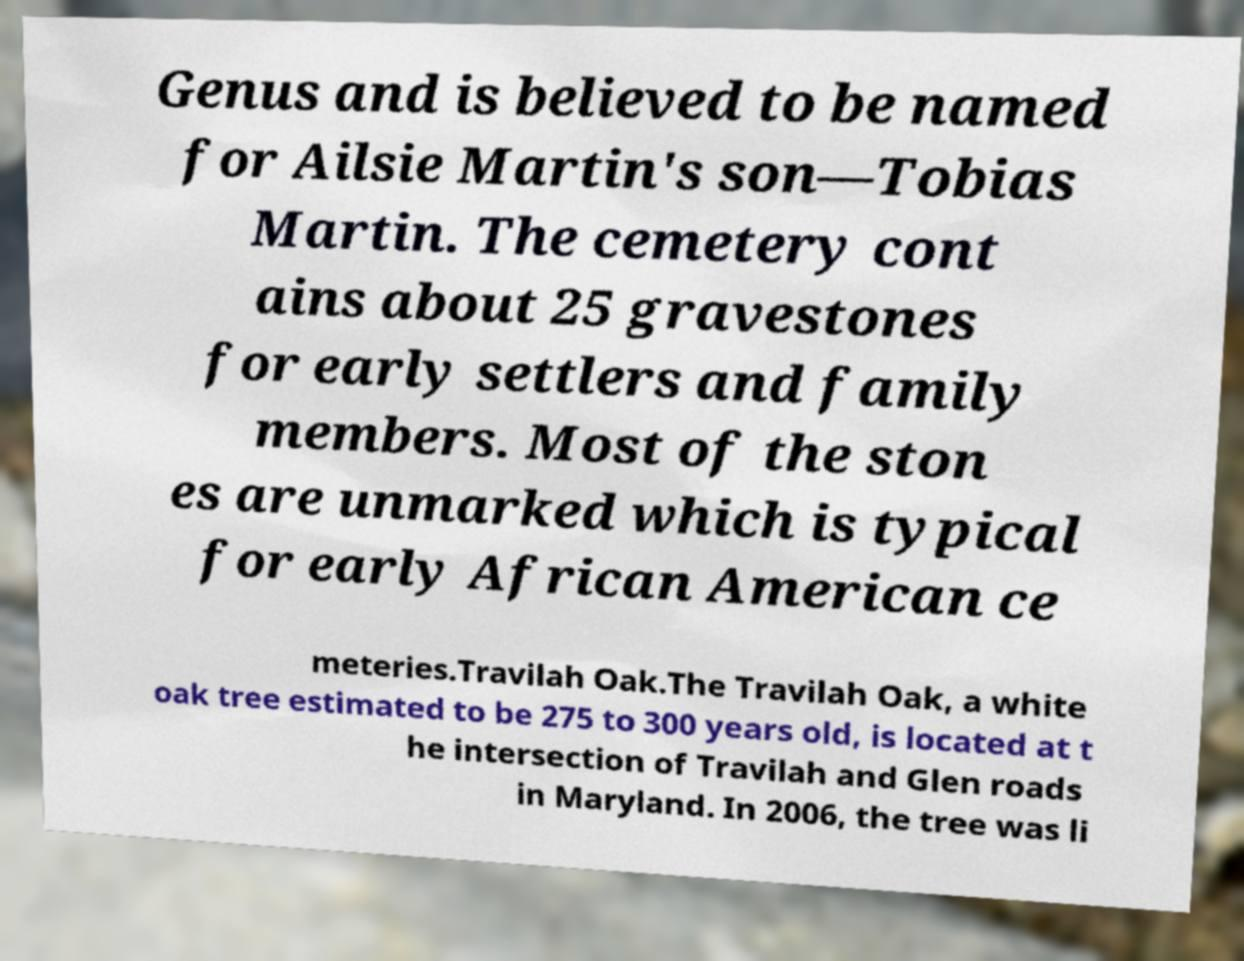Could you assist in decoding the text presented in this image and type it out clearly? Genus and is believed to be named for Ailsie Martin's son—Tobias Martin. The cemetery cont ains about 25 gravestones for early settlers and family members. Most of the ston es are unmarked which is typical for early African American ce meteries.Travilah Oak.The Travilah Oak, a white oak tree estimated to be 275 to 300 years old, is located at t he intersection of Travilah and Glen roads in Maryland. In 2006, the tree was li 